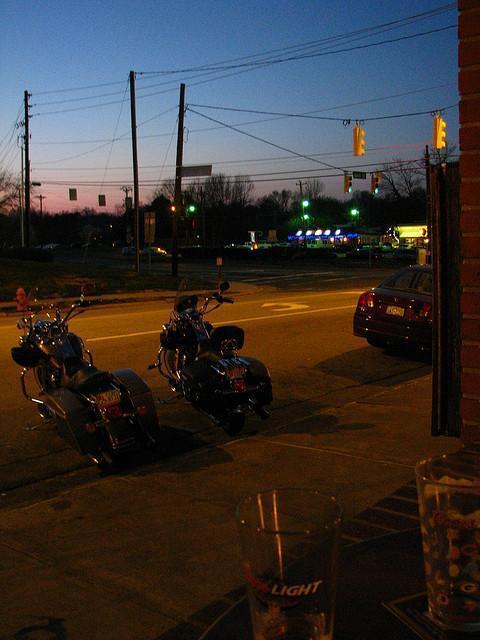How many motorcycles are there?
Give a very brief answer. 2. How many cups can you see?
Give a very brief answer. 2. How many people are on motorcycles?
Give a very brief answer. 0. 